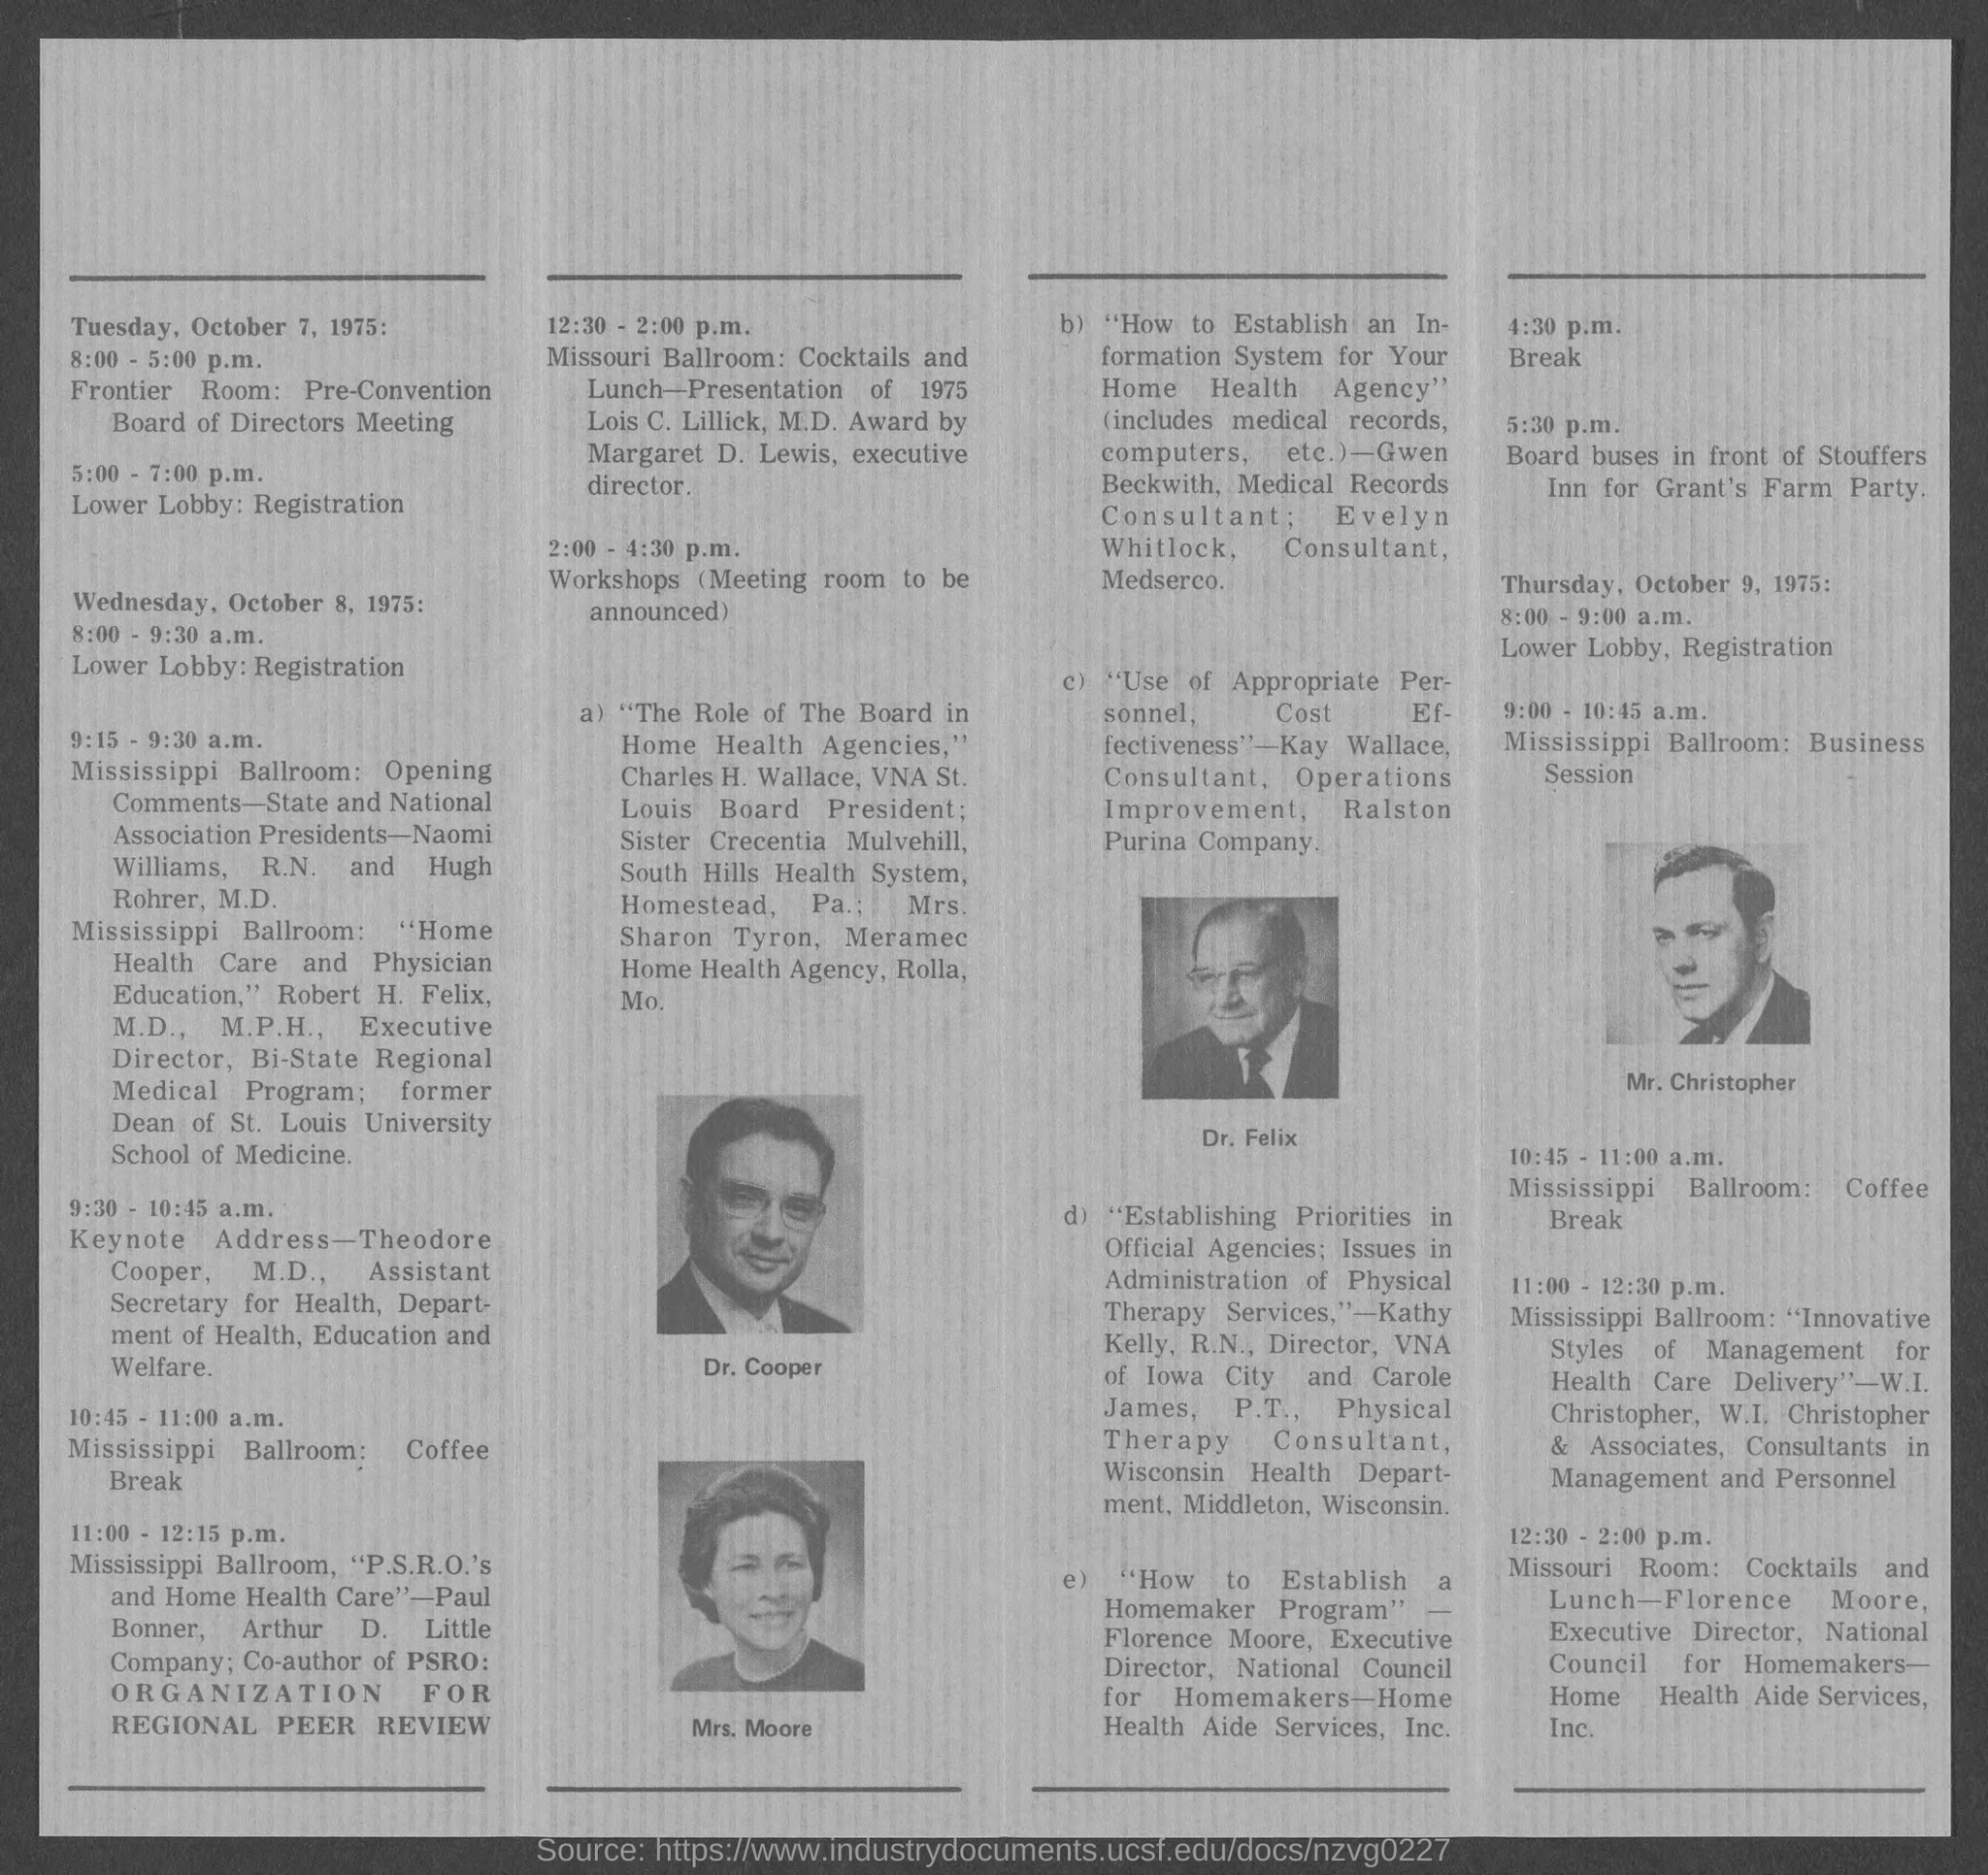On Tuesday, October 7, 1975, where is the meeting?
Offer a terse response. FRONTIER ROOM. Who is giving the Keynote address from 9:30 - 10:45 a.m?
Provide a succinct answer. Theodore Cooper, M.D. What is the topic of Kay Wallace?
Provide a succinct answer. "Use of Appropriate Personnel,  Cost  Effectiveness". 